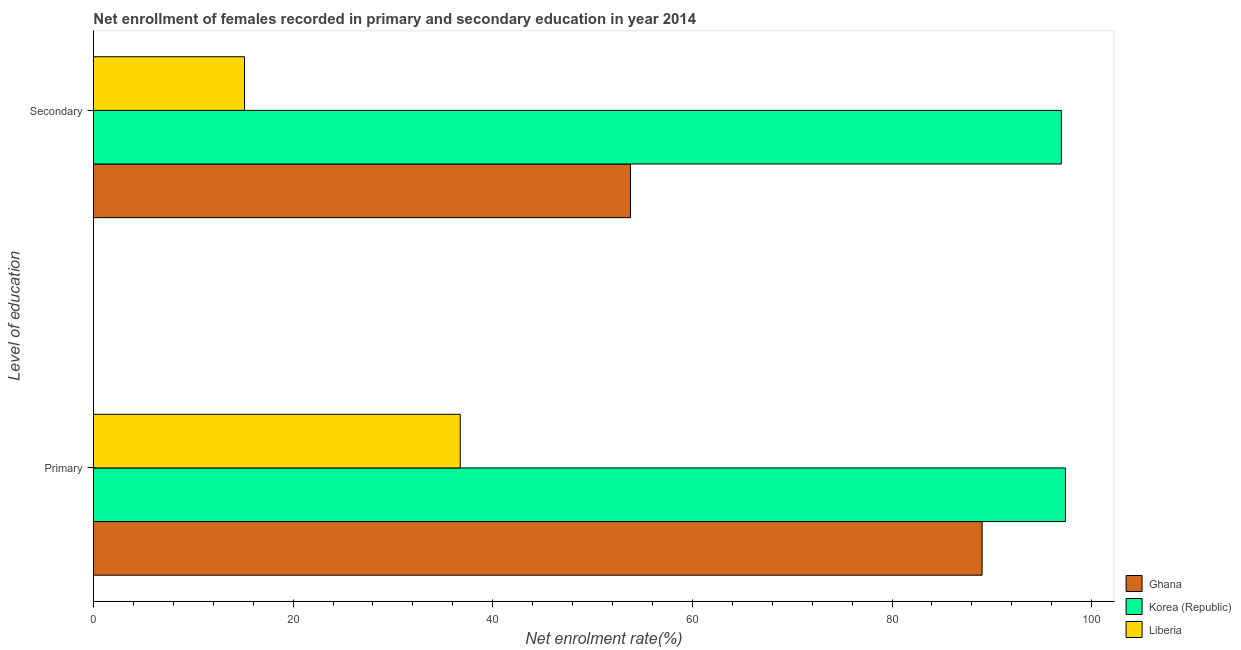How many groups of bars are there?
Provide a succinct answer. 2. Are the number of bars per tick equal to the number of legend labels?
Offer a very short reply. Yes. What is the label of the 1st group of bars from the top?
Your answer should be very brief. Secondary. What is the enrollment rate in primary education in Korea (Republic)?
Ensure brevity in your answer.  97.38. Across all countries, what is the maximum enrollment rate in secondary education?
Ensure brevity in your answer.  96.96. Across all countries, what is the minimum enrollment rate in secondary education?
Offer a terse response. 15.13. In which country was the enrollment rate in secondary education maximum?
Make the answer very short. Korea (Republic). In which country was the enrollment rate in primary education minimum?
Offer a very short reply. Liberia. What is the total enrollment rate in secondary education in the graph?
Make the answer very short. 165.9. What is the difference between the enrollment rate in secondary education in Liberia and that in Ghana?
Provide a short and direct response. -38.67. What is the difference between the enrollment rate in primary education in Korea (Republic) and the enrollment rate in secondary education in Liberia?
Your answer should be very brief. 82.24. What is the average enrollment rate in secondary education per country?
Provide a short and direct response. 55.3. What is the difference between the enrollment rate in secondary education and enrollment rate in primary education in Korea (Republic)?
Provide a short and direct response. -0.41. In how many countries, is the enrollment rate in secondary education greater than 40 %?
Make the answer very short. 2. What is the ratio of the enrollment rate in primary education in Korea (Republic) to that in Ghana?
Your answer should be compact. 1.09. What does the 1st bar from the top in Secondary represents?
Ensure brevity in your answer.  Liberia. What does the 3rd bar from the bottom in Primary represents?
Provide a succinct answer. Liberia. Are all the bars in the graph horizontal?
Offer a very short reply. Yes. How many countries are there in the graph?
Your response must be concise. 3. Are the values on the major ticks of X-axis written in scientific E-notation?
Your answer should be compact. No. Does the graph contain any zero values?
Offer a terse response. No. Does the graph contain grids?
Offer a very short reply. No. How are the legend labels stacked?
Your answer should be compact. Vertical. What is the title of the graph?
Give a very brief answer. Net enrollment of females recorded in primary and secondary education in year 2014. Does "Isle of Man" appear as one of the legend labels in the graph?
Your response must be concise. No. What is the label or title of the X-axis?
Your answer should be very brief. Net enrolment rate(%). What is the label or title of the Y-axis?
Offer a terse response. Level of education. What is the Net enrolment rate(%) in Ghana in Primary?
Offer a terse response. 89.03. What is the Net enrolment rate(%) of Korea (Republic) in Primary?
Your answer should be very brief. 97.38. What is the Net enrolment rate(%) of Liberia in Primary?
Give a very brief answer. 36.74. What is the Net enrolment rate(%) in Ghana in Secondary?
Provide a short and direct response. 53.8. What is the Net enrolment rate(%) in Korea (Republic) in Secondary?
Offer a very short reply. 96.96. What is the Net enrolment rate(%) of Liberia in Secondary?
Make the answer very short. 15.13. Across all Level of education, what is the maximum Net enrolment rate(%) in Ghana?
Provide a succinct answer. 89.03. Across all Level of education, what is the maximum Net enrolment rate(%) in Korea (Republic)?
Your response must be concise. 97.38. Across all Level of education, what is the maximum Net enrolment rate(%) in Liberia?
Your response must be concise. 36.74. Across all Level of education, what is the minimum Net enrolment rate(%) of Ghana?
Provide a succinct answer. 53.8. Across all Level of education, what is the minimum Net enrolment rate(%) in Korea (Republic)?
Ensure brevity in your answer.  96.96. Across all Level of education, what is the minimum Net enrolment rate(%) in Liberia?
Your response must be concise. 15.13. What is the total Net enrolment rate(%) of Ghana in the graph?
Provide a succinct answer. 142.83. What is the total Net enrolment rate(%) in Korea (Republic) in the graph?
Provide a succinct answer. 194.34. What is the total Net enrolment rate(%) of Liberia in the graph?
Provide a succinct answer. 51.88. What is the difference between the Net enrolment rate(%) in Ghana in Primary and that in Secondary?
Make the answer very short. 35.22. What is the difference between the Net enrolment rate(%) of Korea (Republic) in Primary and that in Secondary?
Your answer should be compact. 0.41. What is the difference between the Net enrolment rate(%) of Liberia in Primary and that in Secondary?
Provide a short and direct response. 21.61. What is the difference between the Net enrolment rate(%) in Ghana in Primary and the Net enrolment rate(%) in Korea (Republic) in Secondary?
Your answer should be very brief. -7.94. What is the difference between the Net enrolment rate(%) in Ghana in Primary and the Net enrolment rate(%) in Liberia in Secondary?
Your answer should be very brief. 73.89. What is the difference between the Net enrolment rate(%) in Korea (Republic) in Primary and the Net enrolment rate(%) in Liberia in Secondary?
Make the answer very short. 82.24. What is the average Net enrolment rate(%) of Ghana per Level of education?
Keep it short and to the point. 71.41. What is the average Net enrolment rate(%) in Korea (Republic) per Level of education?
Ensure brevity in your answer.  97.17. What is the average Net enrolment rate(%) of Liberia per Level of education?
Your answer should be very brief. 25.94. What is the difference between the Net enrolment rate(%) of Ghana and Net enrolment rate(%) of Korea (Republic) in Primary?
Offer a terse response. -8.35. What is the difference between the Net enrolment rate(%) of Ghana and Net enrolment rate(%) of Liberia in Primary?
Ensure brevity in your answer.  52.28. What is the difference between the Net enrolment rate(%) of Korea (Republic) and Net enrolment rate(%) of Liberia in Primary?
Ensure brevity in your answer.  60.63. What is the difference between the Net enrolment rate(%) of Ghana and Net enrolment rate(%) of Korea (Republic) in Secondary?
Offer a terse response. -43.16. What is the difference between the Net enrolment rate(%) of Ghana and Net enrolment rate(%) of Liberia in Secondary?
Make the answer very short. 38.67. What is the difference between the Net enrolment rate(%) of Korea (Republic) and Net enrolment rate(%) of Liberia in Secondary?
Your response must be concise. 81.83. What is the ratio of the Net enrolment rate(%) of Ghana in Primary to that in Secondary?
Keep it short and to the point. 1.65. What is the ratio of the Net enrolment rate(%) in Liberia in Primary to that in Secondary?
Your answer should be compact. 2.43. What is the difference between the highest and the second highest Net enrolment rate(%) in Ghana?
Offer a terse response. 35.22. What is the difference between the highest and the second highest Net enrolment rate(%) in Korea (Republic)?
Your response must be concise. 0.41. What is the difference between the highest and the second highest Net enrolment rate(%) in Liberia?
Your response must be concise. 21.61. What is the difference between the highest and the lowest Net enrolment rate(%) of Ghana?
Offer a terse response. 35.22. What is the difference between the highest and the lowest Net enrolment rate(%) in Korea (Republic)?
Offer a very short reply. 0.41. What is the difference between the highest and the lowest Net enrolment rate(%) in Liberia?
Give a very brief answer. 21.61. 